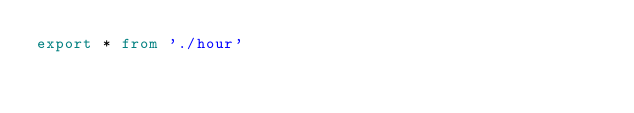Convert code to text. <code><loc_0><loc_0><loc_500><loc_500><_TypeScript_>export * from './hour'
</code> 